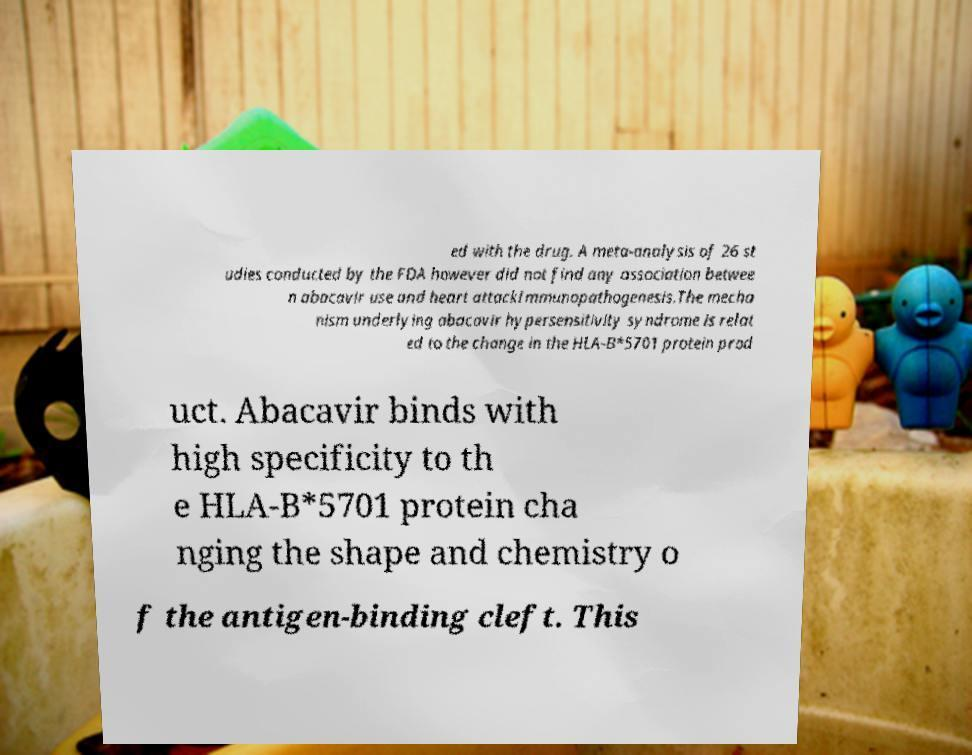For documentation purposes, I need the text within this image transcribed. Could you provide that? ed with the drug. A meta-analysis of 26 st udies conducted by the FDA however did not find any association betwee n abacavir use and heart attackImmunopathogenesis.The mecha nism underlying abacavir hypersensitivity syndrome is relat ed to the change in the HLA-B*5701 protein prod uct. Abacavir binds with high specificity to th e HLA-B*5701 protein cha nging the shape and chemistry o f the antigen-binding cleft. This 